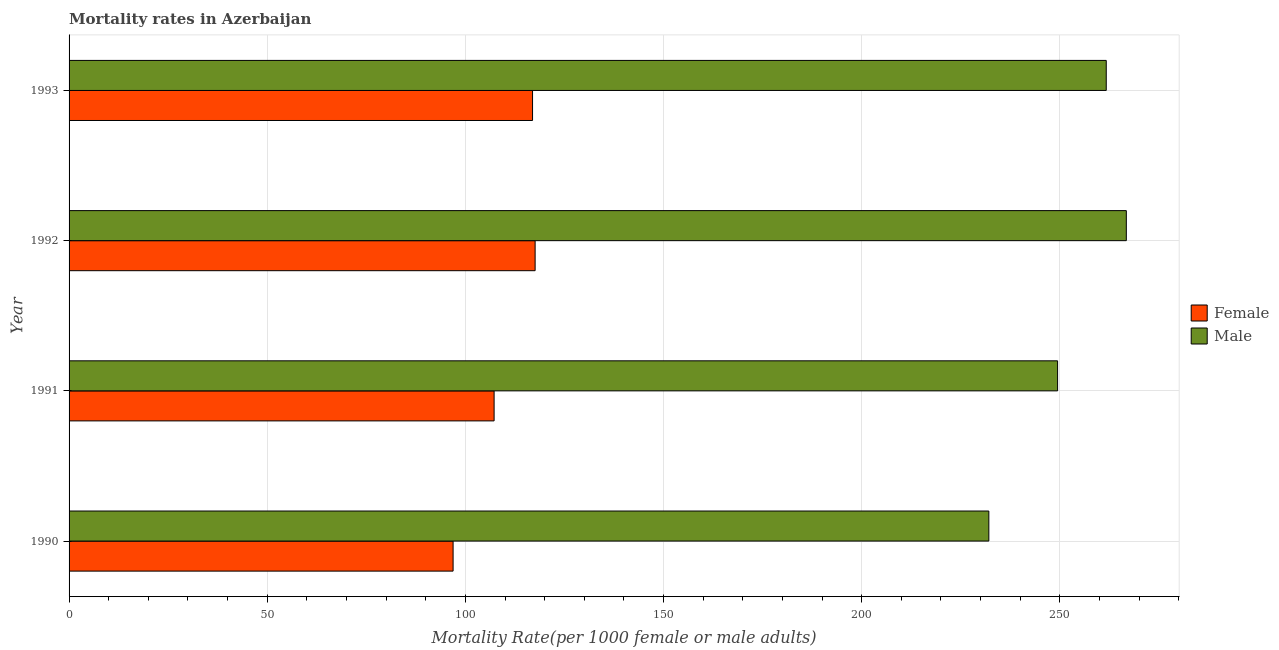How many different coloured bars are there?
Provide a short and direct response. 2. How many groups of bars are there?
Offer a very short reply. 4. Are the number of bars per tick equal to the number of legend labels?
Your answer should be very brief. Yes. Are the number of bars on each tick of the Y-axis equal?
Your answer should be very brief. Yes. How many bars are there on the 4th tick from the bottom?
Your answer should be very brief. 2. What is the label of the 2nd group of bars from the top?
Keep it short and to the point. 1992. What is the female mortality rate in 1991?
Your answer should be compact. 107.25. Across all years, what is the maximum female mortality rate?
Ensure brevity in your answer.  117.59. Across all years, what is the minimum female mortality rate?
Ensure brevity in your answer.  96.9. In which year was the female mortality rate maximum?
Your answer should be compact. 1992. What is the total male mortality rate in the graph?
Provide a short and direct response. 1009.99. What is the difference between the male mortality rate in 1990 and that in 1991?
Give a very brief answer. -17.35. What is the difference between the male mortality rate in 1993 and the female mortality rate in 1991?
Make the answer very short. 154.46. What is the average female mortality rate per year?
Offer a very short reply. 109.67. In the year 1993, what is the difference between the female mortality rate and male mortality rate?
Make the answer very short. -144.76. What is the ratio of the female mortality rate in 1990 to that in 1992?
Your answer should be very brief. 0.82. Is the female mortality rate in 1990 less than that in 1993?
Keep it short and to the point. Yes. Is the difference between the female mortality rate in 1991 and 1993 greater than the difference between the male mortality rate in 1991 and 1993?
Make the answer very short. Yes. What is the difference between the highest and the second highest female mortality rate?
Provide a short and direct response. 0.65. What is the difference between the highest and the lowest male mortality rate?
Give a very brief answer. 34.69. In how many years, is the female mortality rate greater than the average female mortality rate taken over all years?
Your answer should be very brief. 2. Is the sum of the female mortality rate in 1990 and 1992 greater than the maximum male mortality rate across all years?
Offer a terse response. No. What does the 2nd bar from the top in 1992 represents?
Your answer should be compact. Female. Does the graph contain any zero values?
Offer a terse response. No. Does the graph contain grids?
Ensure brevity in your answer.  Yes. How are the legend labels stacked?
Provide a succinct answer. Vertical. What is the title of the graph?
Give a very brief answer. Mortality rates in Azerbaijan. Does "Transport services" appear as one of the legend labels in the graph?
Offer a terse response. No. What is the label or title of the X-axis?
Give a very brief answer. Mortality Rate(per 1000 female or male adults). What is the label or title of the Y-axis?
Give a very brief answer. Year. What is the Mortality Rate(per 1000 female or male adults) in Female in 1990?
Give a very brief answer. 96.9. What is the Mortality Rate(per 1000 female or male adults) of Male in 1990?
Offer a very short reply. 232.08. What is the Mortality Rate(per 1000 female or male adults) in Female in 1991?
Provide a succinct answer. 107.25. What is the Mortality Rate(per 1000 female or male adults) of Male in 1991?
Keep it short and to the point. 249.43. What is the Mortality Rate(per 1000 female or male adults) in Female in 1992?
Your answer should be very brief. 117.59. What is the Mortality Rate(per 1000 female or male adults) in Male in 1992?
Ensure brevity in your answer.  266.77. What is the Mortality Rate(per 1000 female or male adults) of Female in 1993?
Make the answer very short. 116.95. What is the Mortality Rate(per 1000 female or male adults) of Male in 1993?
Your answer should be compact. 261.71. Across all years, what is the maximum Mortality Rate(per 1000 female or male adults) of Female?
Provide a succinct answer. 117.59. Across all years, what is the maximum Mortality Rate(per 1000 female or male adults) of Male?
Your answer should be very brief. 266.77. Across all years, what is the minimum Mortality Rate(per 1000 female or male adults) of Female?
Offer a very short reply. 96.9. Across all years, what is the minimum Mortality Rate(per 1000 female or male adults) in Male?
Provide a succinct answer. 232.08. What is the total Mortality Rate(per 1000 female or male adults) of Female in the graph?
Offer a very short reply. 438.69. What is the total Mortality Rate(per 1000 female or male adults) in Male in the graph?
Offer a very short reply. 1009.99. What is the difference between the Mortality Rate(per 1000 female or male adults) of Female in 1990 and that in 1991?
Keep it short and to the point. -10.35. What is the difference between the Mortality Rate(per 1000 female or male adults) in Male in 1990 and that in 1991?
Provide a succinct answer. -17.35. What is the difference between the Mortality Rate(per 1000 female or male adults) in Female in 1990 and that in 1992?
Provide a succinct answer. -20.69. What is the difference between the Mortality Rate(per 1000 female or male adults) of Male in 1990 and that in 1992?
Your answer should be compact. -34.69. What is the difference between the Mortality Rate(per 1000 female or male adults) in Female in 1990 and that in 1993?
Keep it short and to the point. -20.05. What is the difference between the Mortality Rate(per 1000 female or male adults) in Male in 1990 and that in 1993?
Your response must be concise. -29.62. What is the difference between the Mortality Rate(per 1000 female or male adults) in Female in 1991 and that in 1992?
Provide a succinct answer. -10.35. What is the difference between the Mortality Rate(per 1000 female or male adults) of Male in 1991 and that in 1992?
Offer a terse response. -17.35. What is the difference between the Mortality Rate(per 1000 female or male adults) in Female in 1991 and that in 1993?
Provide a succinct answer. -9.7. What is the difference between the Mortality Rate(per 1000 female or male adults) in Male in 1991 and that in 1993?
Your answer should be compact. -12.28. What is the difference between the Mortality Rate(per 1000 female or male adults) of Female in 1992 and that in 1993?
Offer a very short reply. 0.65. What is the difference between the Mortality Rate(per 1000 female or male adults) in Male in 1992 and that in 1993?
Ensure brevity in your answer.  5.07. What is the difference between the Mortality Rate(per 1000 female or male adults) in Female in 1990 and the Mortality Rate(per 1000 female or male adults) in Male in 1991?
Ensure brevity in your answer.  -152.53. What is the difference between the Mortality Rate(per 1000 female or male adults) of Female in 1990 and the Mortality Rate(per 1000 female or male adults) of Male in 1992?
Your answer should be compact. -169.87. What is the difference between the Mortality Rate(per 1000 female or male adults) in Female in 1990 and the Mortality Rate(per 1000 female or male adults) in Male in 1993?
Provide a succinct answer. -164.81. What is the difference between the Mortality Rate(per 1000 female or male adults) of Female in 1991 and the Mortality Rate(per 1000 female or male adults) of Male in 1992?
Your response must be concise. -159.53. What is the difference between the Mortality Rate(per 1000 female or male adults) of Female in 1991 and the Mortality Rate(per 1000 female or male adults) of Male in 1993?
Your answer should be very brief. -154.46. What is the difference between the Mortality Rate(per 1000 female or male adults) in Female in 1992 and the Mortality Rate(per 1000 female or male adults) in Male in 1993?
Your answer should be very brief. -144.11. What is the average Mortality Rate(per 1000 female or male adults) of Female per year?
Ensure brevity in your answer.  109.67. What is the average Mortality Rate(per 1000 female or male adults) in Male per year?
Make the answer very short. 252.5. In the year 1990, what is the difference between the Mortality Rate(per 1000 female or male adults) in Female and Mortality Rate(per 1000 female or male adults) in Male?
Your answer should be compact. -135.18. In the year 1991, what is the difference between the Mortality Rate(per 1000 female or male adults) in Female and Mortality Rate(per 1000 female or male adults) in Male?
Provide a succinct answer. -142.18. In the year 1992, what is the difference between the Mortality Rate(per 1000 female or male adults) of Female and Mortality Rate(per 1000 female or male adults) of Male?
Your response must be concise. -149.18. In the year 1993, what is the difference between the Mortality Rate(per 1000 female or male adults) of Female and Mortality Rate(per 1000 female or male adults) of Male?
Offer a very short reply. -144.76. What is the ratio of the Mortality Rate(per 1000 female or male adults) of Female in 1990 to that in 1991?
Keep it short and to the point. 0.9. What is the ratio of the Mortality Rate(per 1000 female or male adults) in Male in 1990 to that in 1991?
Your answer should be very brief. 0.93. What is the ratio of the Mortality Rate(per 1000 female or male adults) in Female in 1990 to that in 1992?
Ensure brevity in your answer.  0.82. What is the ratio of the Mortality Rate(per 1000 female or male adults) in Male in 1990 to that in 1992?
Your answer should be very brief. 0.87. What is the ratio of the Mortality Rate(per 1000 female or male adults) in Female in 1990 to that in 1993?
Offer a very short reply. 0.83. What is the ratio of the Mortality Rate(per 1000 female or male adults) of Male in 1990 to that in 1993?
Offer a terse response. 0.89. What is the ratio of the Mortality Rate(per 1000 female or male adults) in Female in 1991 to that in 1992?
Ensure brevity in your answer.  0.91. What is the ratio of the Mortality Rate(per 1000 female or male adults) of Male in 1991 to that in 1992?
Offer a terse response. 0.94. What is the ratio of the Mortality Rate(per 1000 female or male adults) of Female in 1991 to that in 1993?
Make the answer very short. 0.92. What is the ratio of the Mortality Rate(per 1000 female or male adults) of Male in 1991 to that in 1993?
Provide a succinct answer. 0.95. What is the ratio of the Mortality Rate(per 1000 female or male adults) in Male in 1992 to that in 1993?
Provide a succinct answer. 1.02. What is the difference between the highest and the second highest Mortality Rate(per 1000 female or male adults) in Female?
Make the answer very short. 0.65. What is the difference between the highest and the second highest Mortality Rate(per 1000 female or male adults) in Male?
Your response must be concise. 5.07. What is the difference between the highest and the lowest Mortality Rate(per 1000 female or male adults) in Female?
Keep it short and to the point. 20.69. What is the difference between the highest and the lowest Mortality Rate(per 1000 female or male adults) of Male?
Keep it short and to the point. 34.69. 